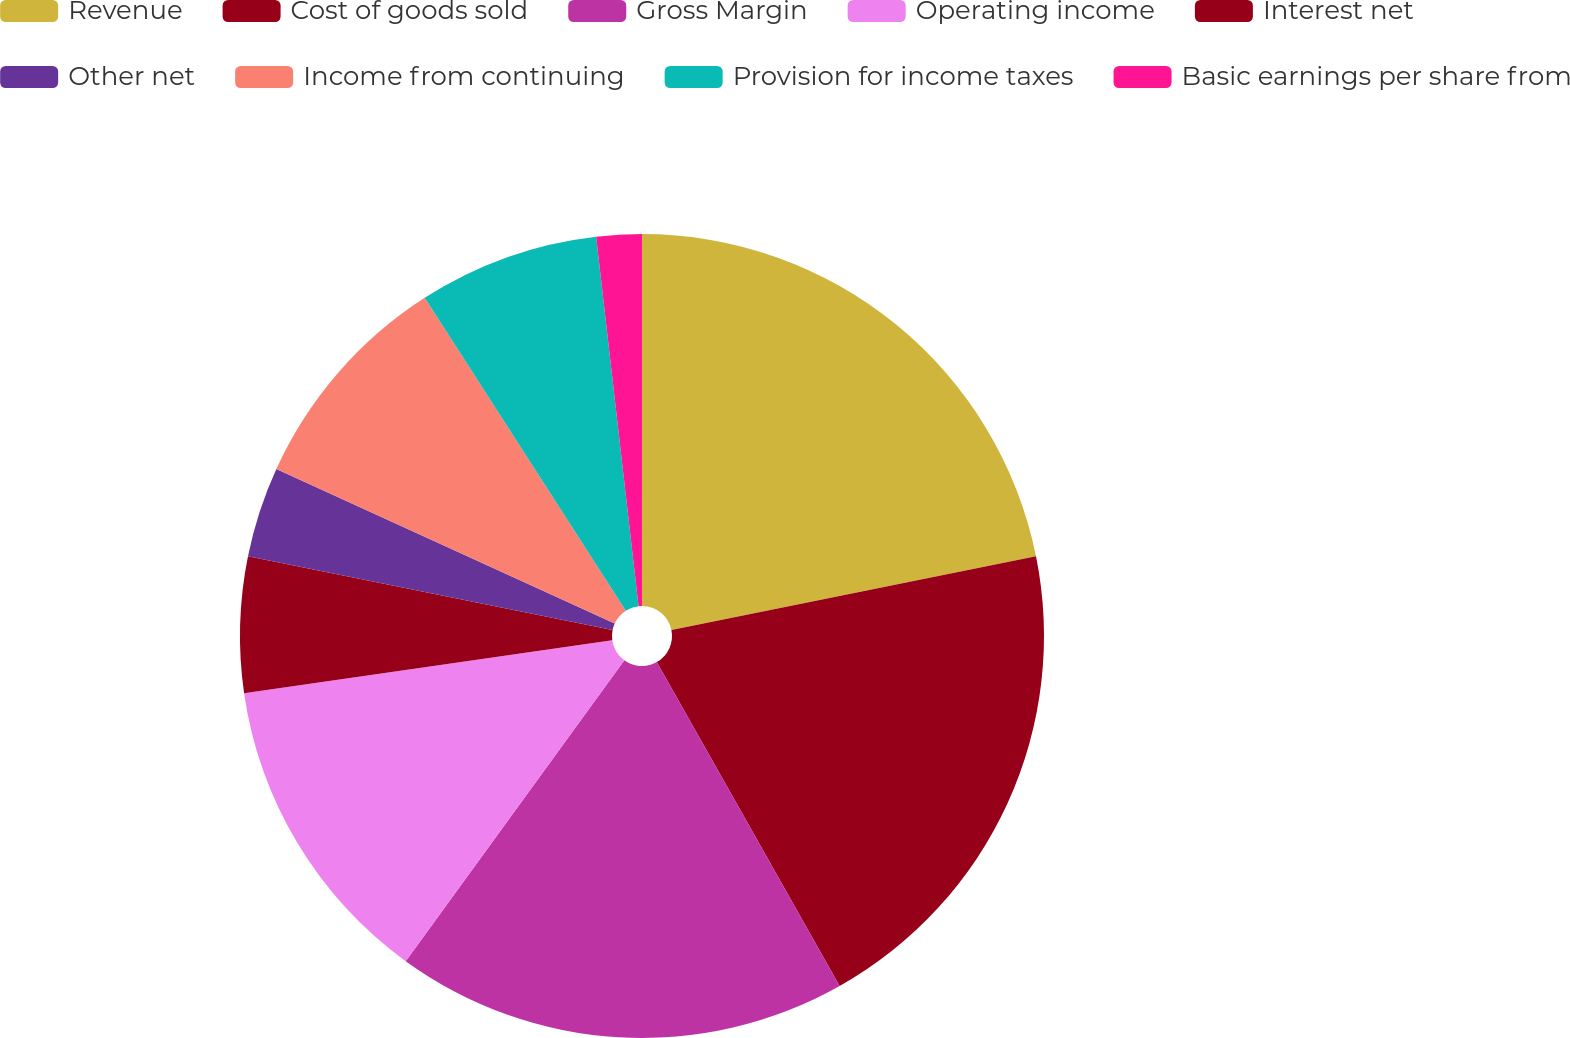<chart> <loc_0><loc_0><loc_500><loc_500><pie_chart><fcel>Revenue<fcel>Cost of goods sold<fcel>Gross Margin<fcel>Operating income<fcel>Interest net<fcel>Other net<fcel>Income from continuing<fcel>Provision for income taxes<fcel>Basic earnings per share from<nl><fcel>21.82%<fcel>20.0%<fcel>18.18%<fcel>12.73%<fcel>5.45%<fcel>3.64%<fcel>9.09%<fcel>7.27%<fcel>1.82%<nl></chart> 